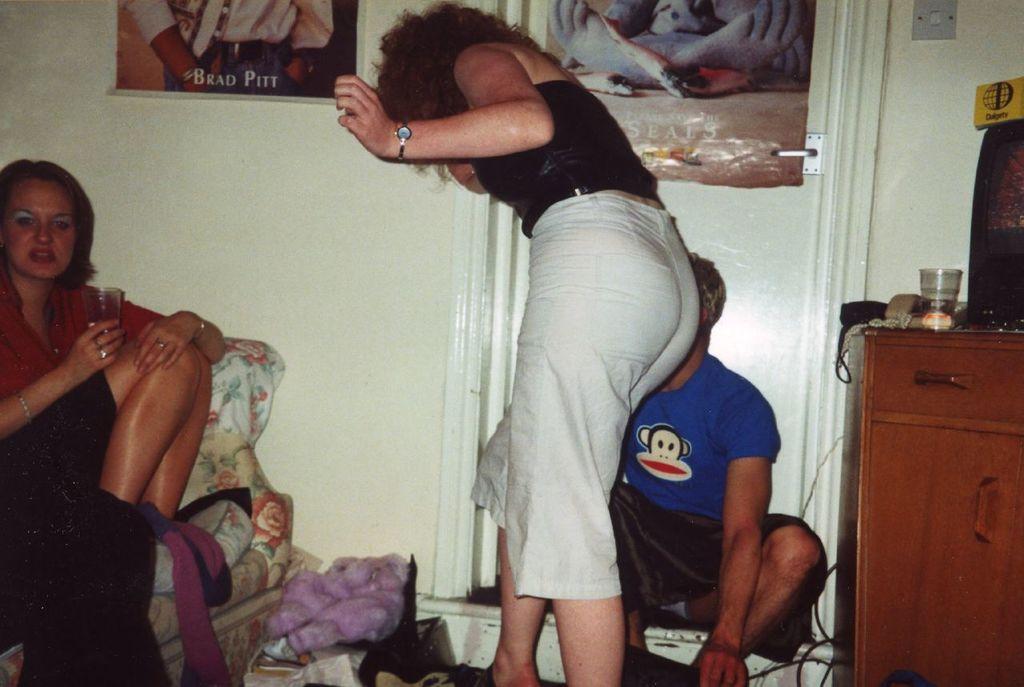How would you summarize this image in a sentence or two? In this picture we can see group of people, on the right side of the image we can see a woman, she is seated on the sofa and she is holding a glass, beside to them we can see a glass, telephone and other things on the table, in the background we can see few posts and a door. 